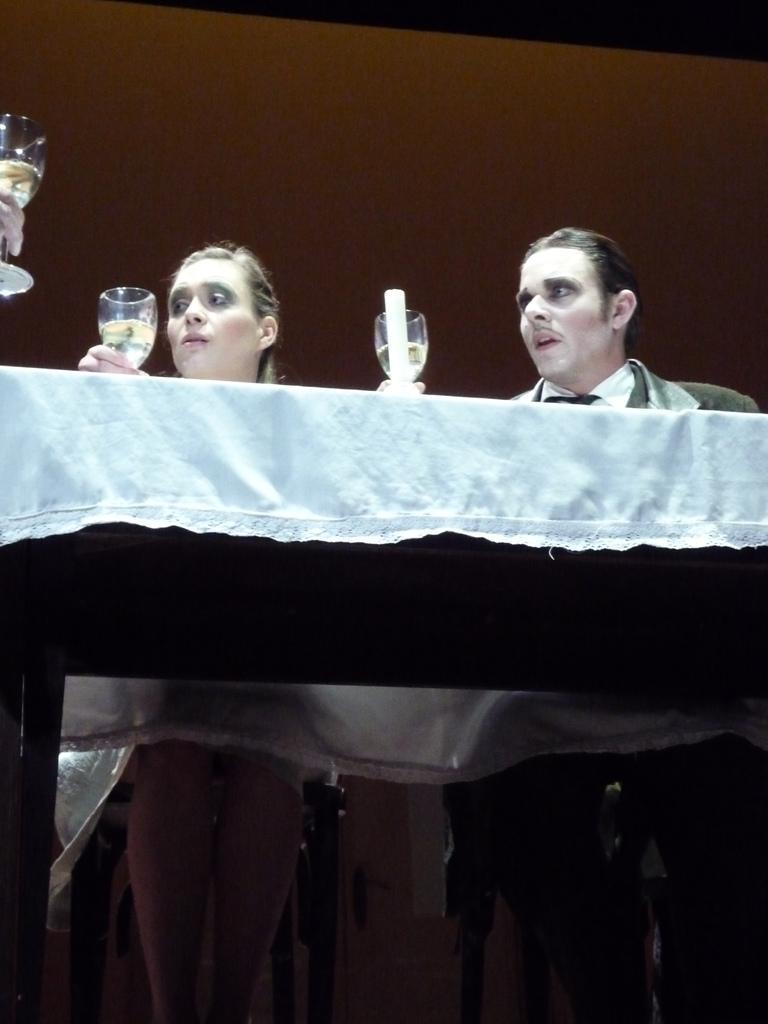Could you give a brief overview of what you see in this image? There is a woman and a man sitting on chairs. There is a table in front of them. They are holding glasses. A candle is on the table. 